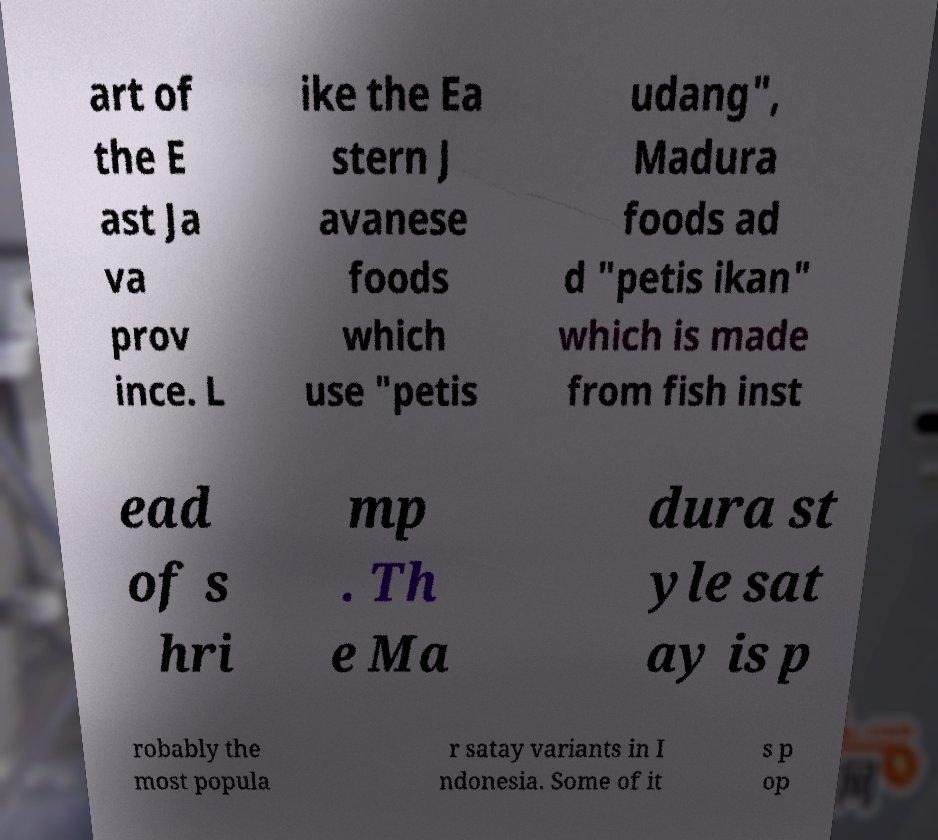Can you read and provide the text displayed in the image?This photo seems to have some interesting text. Can you extract and type it out for me? art of the E ast Ja va prov ince. L ike the Ea stern J avanese foods which use "petis udang", Madura foods ad d "petis ikan" which is made from fish inst ead of s hri mp . Th e Ma dura st yle sat ay is p robably the most popula r satay variants in I ndonesia. Some of it s p op 